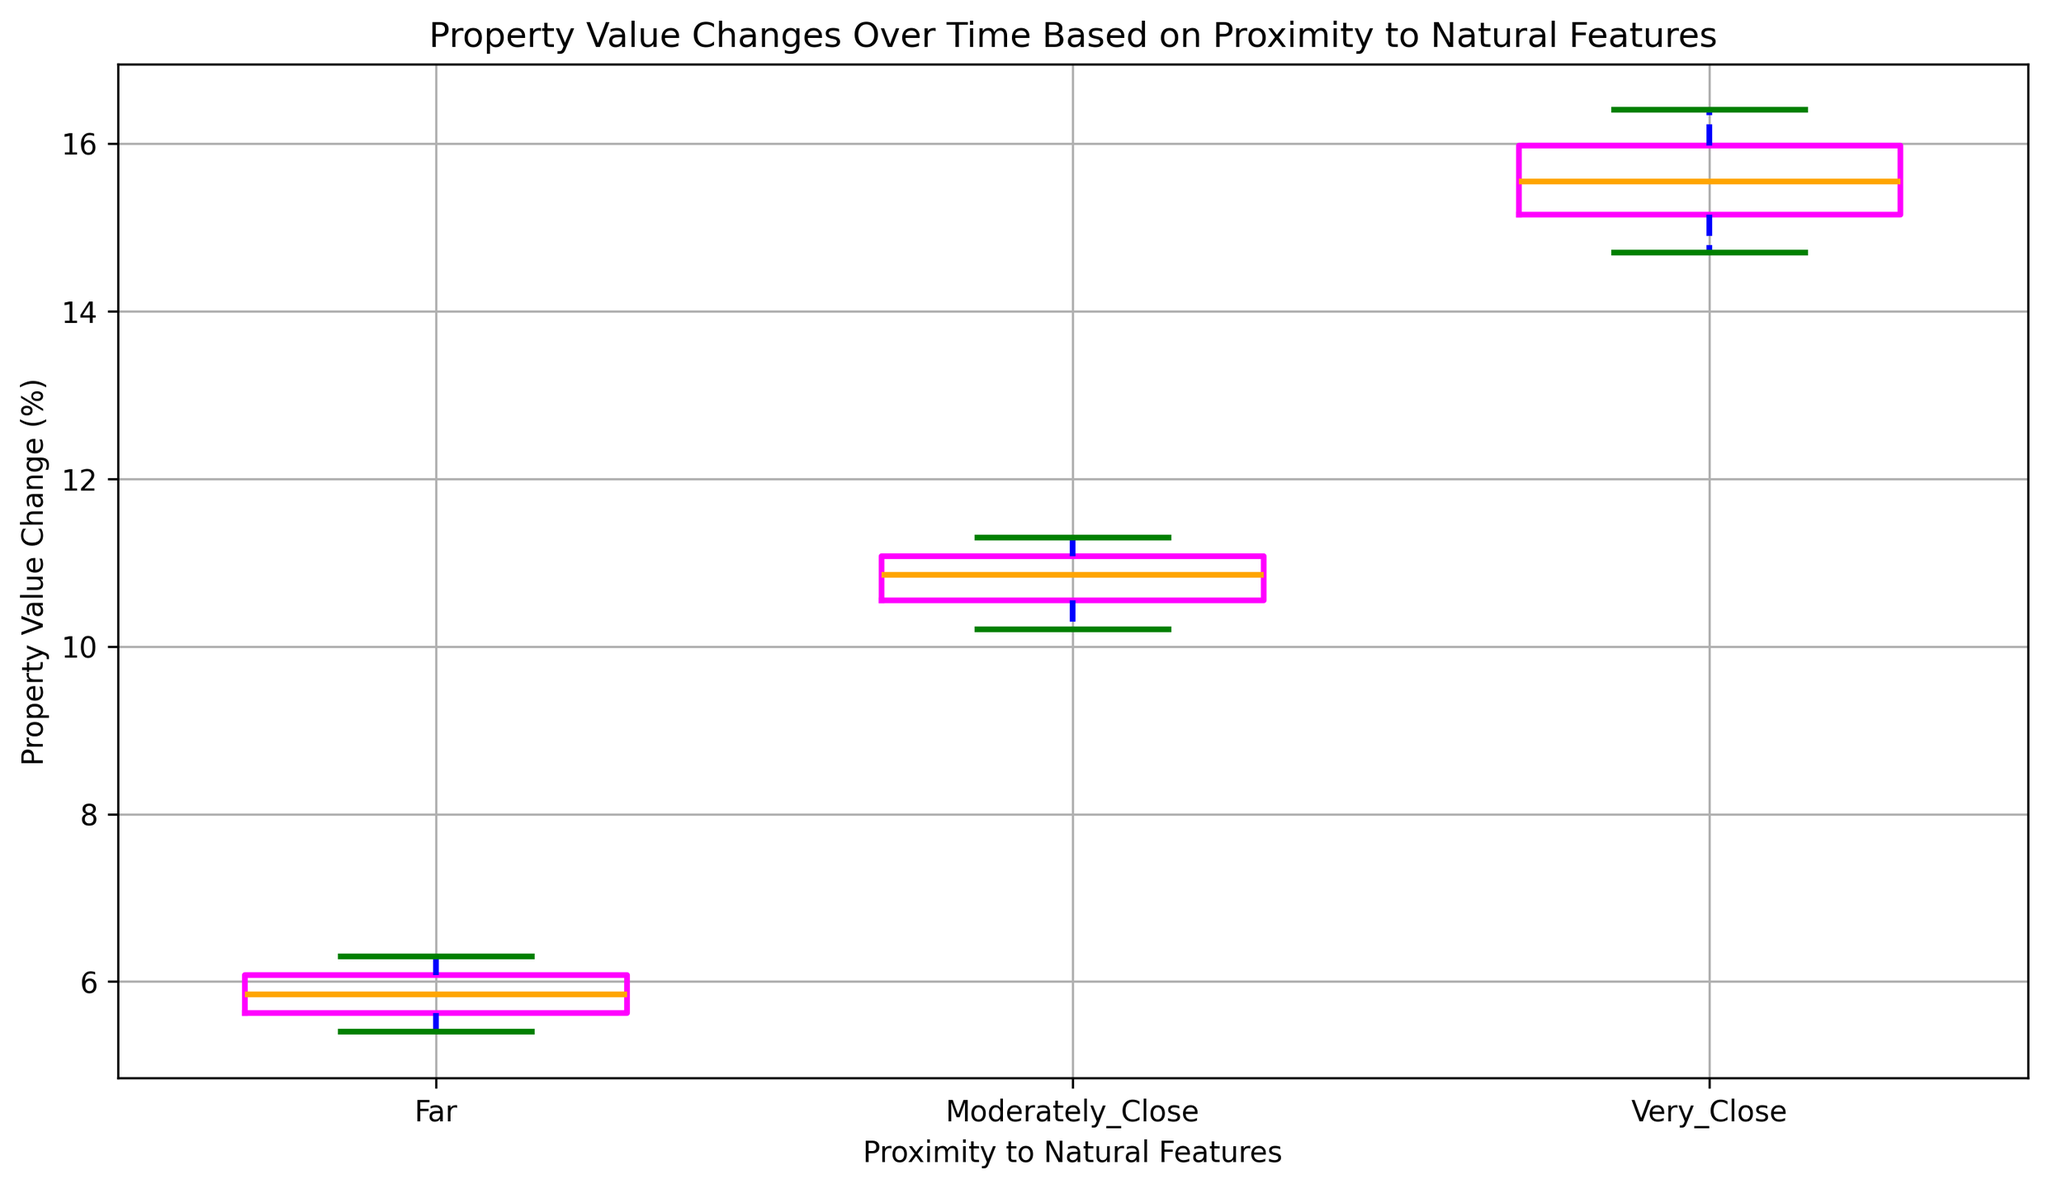What is the median property value change for properties that are very close to natural features? Look at the median line (orange) within the box for the 'Very_Close' category. The line's position represents the median value.
Answer: 15.5 How does the median property value change for properties that are moderately close to natural features compare to those that are far? Compare the median lines (orange) in the 'Moderately_Close' box and the 'Far' box.
Answer: Moderately close is higher than far What is the interquartile range (IQR) for properties that are very close to natural features? The IQR is calculated by subtracting the lower quartile value (bottom of the box) from the upper quartile value (top of the box) for the 'Very_Close' category.
Answer: 0.9 Which category shows the greatest variability in property value changes? Variability can be assessed by looking at the length of the boxes and the spread of the whiskers.
Answer: Very close What is the minimum property value change for the 'Far' category? The minimum change is defined by the lowest point of the whiskers in the 'Far' category.
Answer: 5.4 How do the mean property value change for properties that are very close to natural features and moderately close compare? While the mean is not directly shown, a rough estimate can be made by observing the central tendency within each box.
Answer: Very close is higher than moderately close Are there any outliers in the 'Far' category, and if so, how are they visually represented? Outliers would be represented by red dots outside the whiskers in the 'Far' category.
Answer: No outliers What is the range of property value changes for properties that are moderately close to natural features? The range is calculated by subtracting the minimum value (bottom whisker) from the maximum value (top whisker) in the 'Moderately_Close' category.
Answer: 1.1 Between all three categories, which one shows the smallest spread in property value changes? The spread is the range between the top and bottom whiskers.
Answer: Far What is the difference between the medians of 'Very_Close' and 'Far' properties? Subtract the median value of the 'Far' category from the median value of the 'Very_Close' category.
Answer: 9.5 